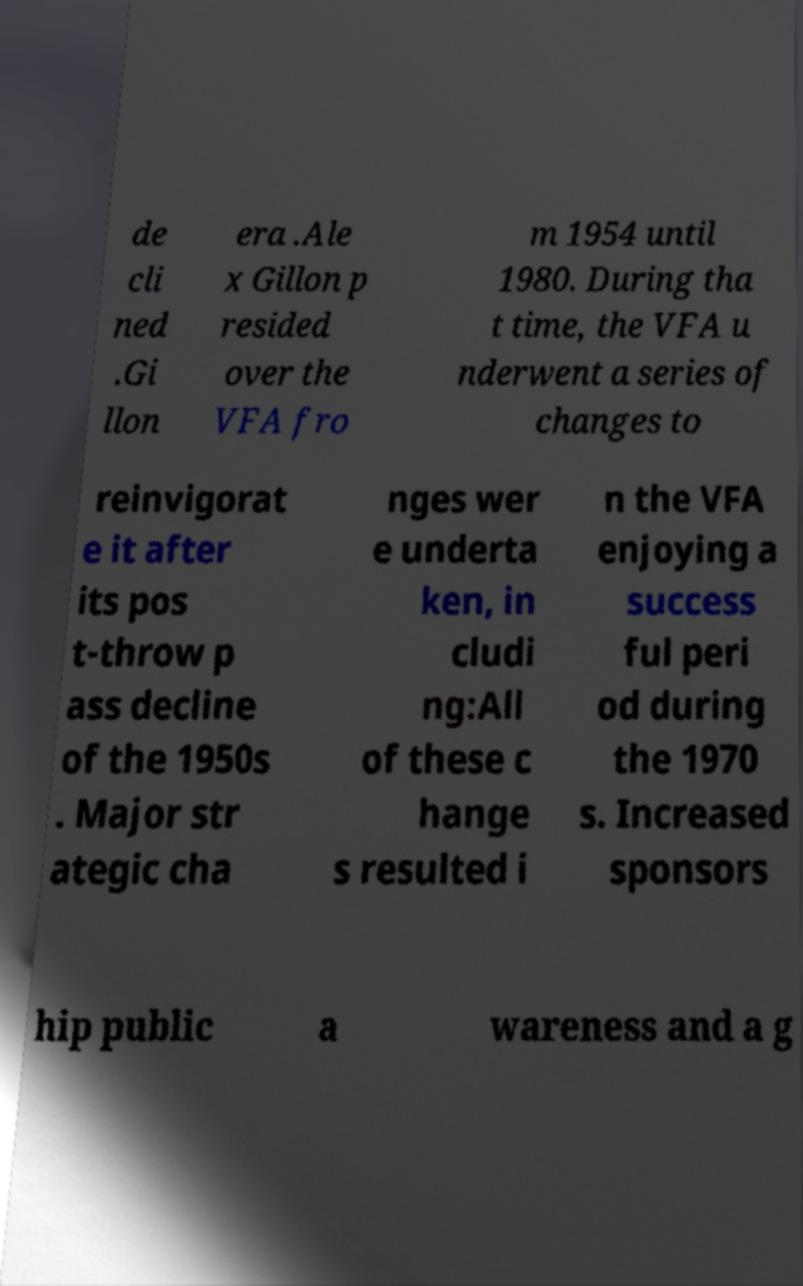Could you assist in decoding the text presented in this image and type it out clearly? de cli ned .Gi llon era .Ale x Gillon p resided over the VFA fro m 1954 until 1980. During tha t time, the VFA u nderwent a series of changes to reinvigorat e it after its pos t-throw p ass decline of the 1950s . Major str ategic cha nges wer e underta ken, in cludi ng:All of these c hange s resulted i n the VFA enjoying a success ful peri od during the 1970 s. Increased sponsors hip public a wareness and a g 